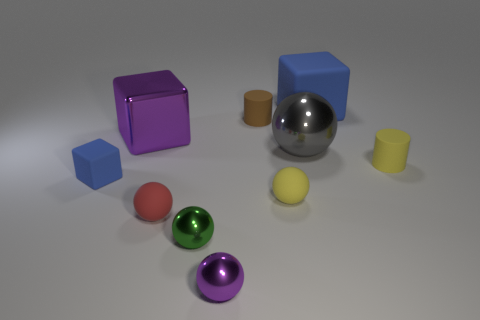There is a cube that is both behind the small blue matte block and to the left of the tiny red rubber ball; what material is it?
Offer a very short reply. Metal. There is a metal sphere that is behind the rubber block to the left of the cylinder on the left side of the big blue matte block; what size is it?
Provide a short and direct response. Large. There is a small green thing; is its shape the same as the tiny rubber thing on the left side of the red ball?
Give a very brief answer. No. What number of tiny things are on the left side of the green shiny sphere and on the right side of the big purple cube?
Your answer should be compact. 1. What number of yellow objects are either tiny cylinders or large shiny blocks?
Make the answer very short. 1. There is a rubber thing behind the small brown cylinder; is its color the same as the shiny block in front of the small brown object?
Give a very brief answer. No. What is the color of the cylinder to the left of the yellow matte cylinder on the right side of the blue cube that is in front of the small yellow cylinder?
Your response must be concise. Brown. Is there a small purple sphere that is behind the tiny yellow object that is to the right of the large blue cube?
Offer a very short reply. No. Do the large metallic object that is on the right side of the green sphere and the small blue matte thing have the same shape?
Make the answer very short. No. What number of blocks are big brown things or tiny rubber things?
Keep it short and to the point. 1. 